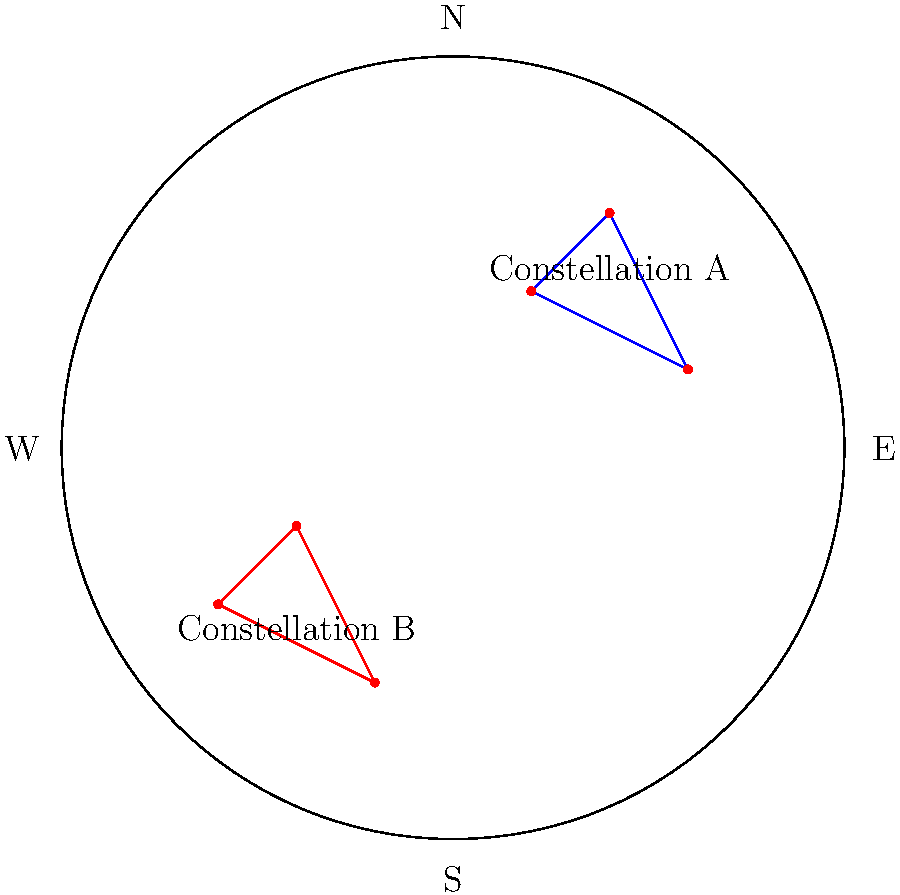In the given star chart, which constellation is located in the northern part of the sky? To determine which constellation is in the northern part of the sky, we need to follow these steps:

1. Identify the compass directions on the star chart:
   - North (N) is at the top of the chart
   - South (S) is at the bottom
   - East (E) is to the right
   - West (W) is to the left

2. Locate the constellations on the chart:
   - Constellation A is in the upper right quadrant
   - Constellation B is in the lower left quadrant

3. Compare the positions of the constellations relative to the compass directions:
   - Constellation A is closer to the North (N) label
   - Constellation B is closer to the South (S) label

4. Conclude that Constellation A is located in the northern part of the sky, as it is positioned above the center of the chart and closer to the North label.

This analysis allows us to determine that Constellation A is the one located in the northern part of the sky.
Answer: Constellation A 